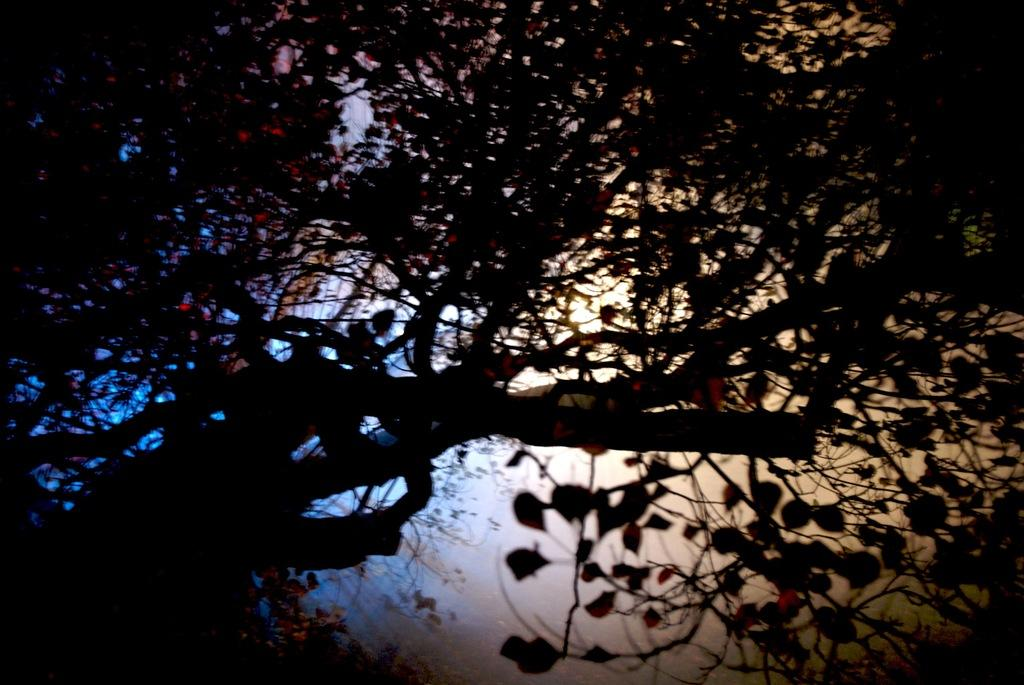What is the main subject in the foreground of the image? There is a tree with leaves and branches in the image. What can be seen in the background of the image? There are trees in the background of the image. What is visible in the sky in the image? There are clouds in the sky, and the sky is blue. What type of quilt is being used to cover the farmer in the image? There is no farmer or quilt present in the image; it features a tree with leaves and branches, trees in the background, clouds, and a blue sky. 